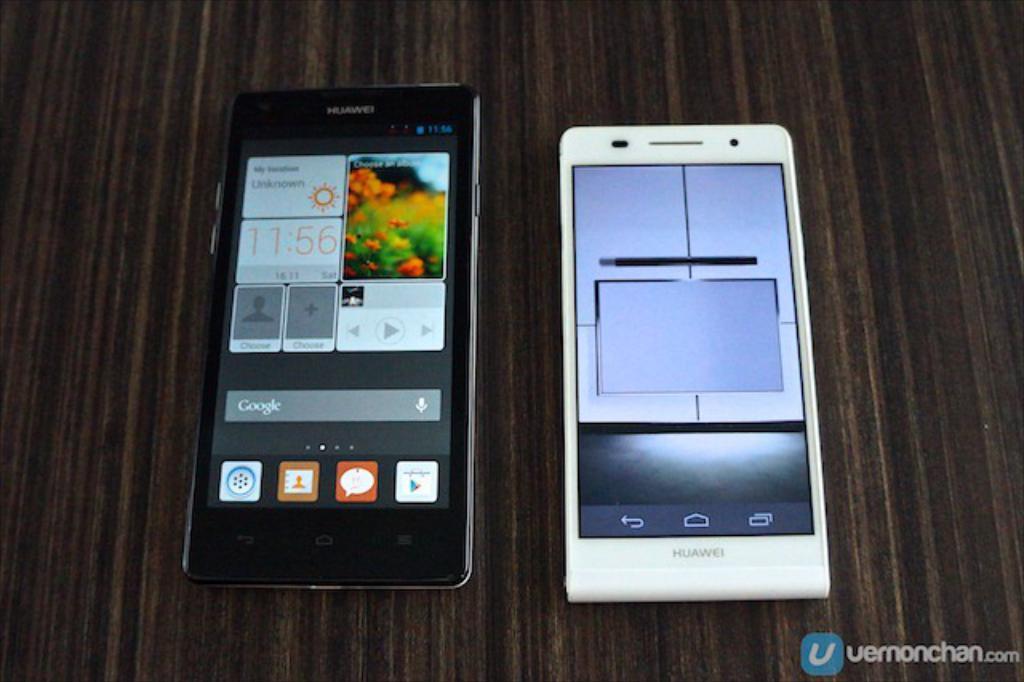<image>
Offer a succinct explanation of the picture presented. black huawei phone next to a white on on a wood surface and website at bottom uernonchan.com 